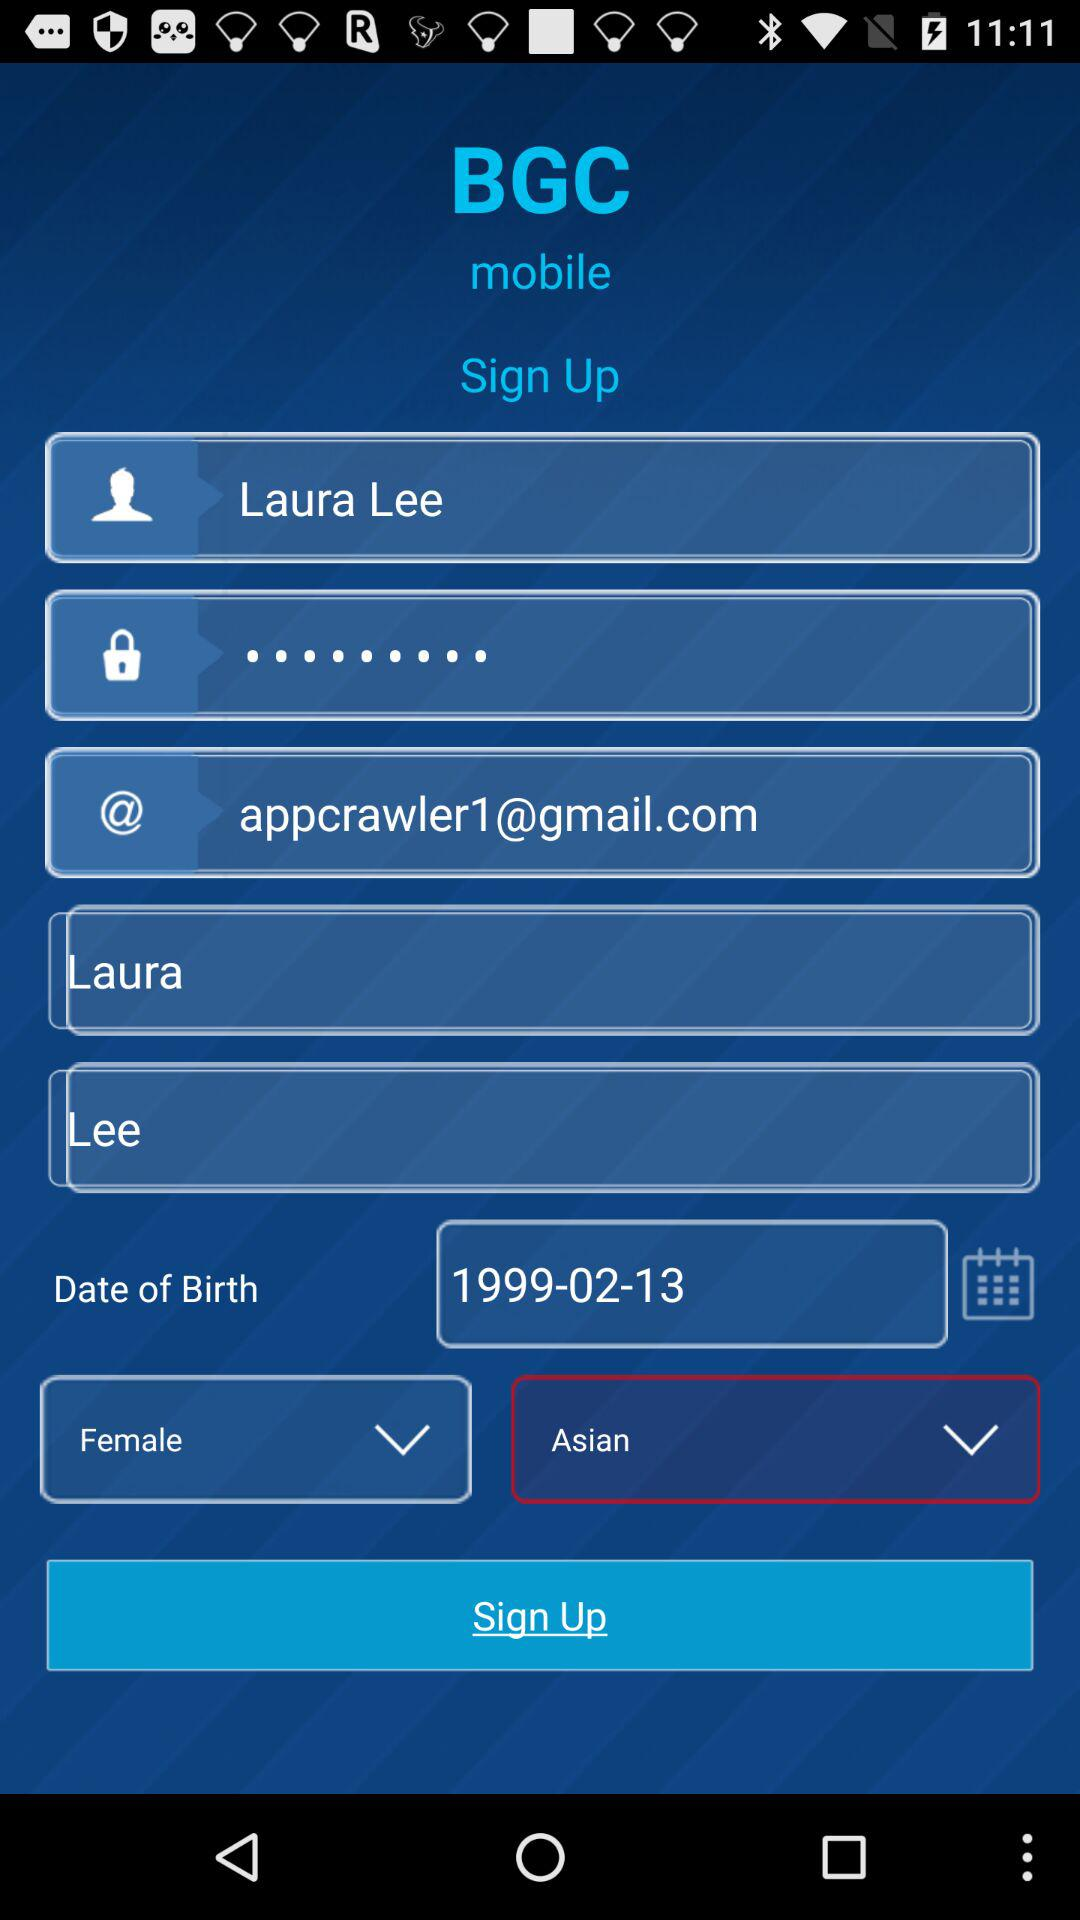What is the user name? The user name is Laura Lee. 